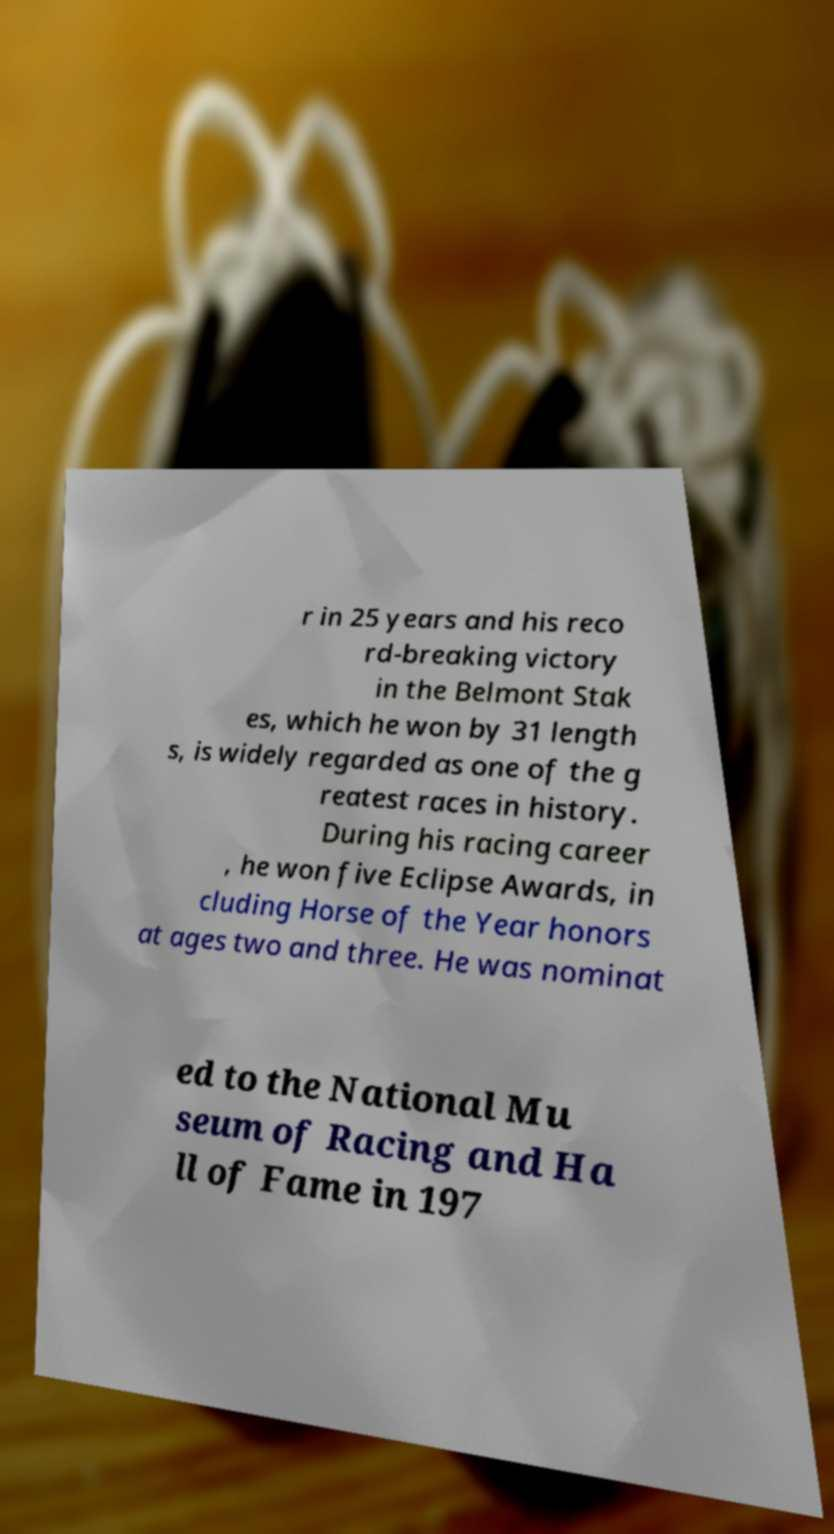Please read and relay the text visible in this image. What does it say? r in 25 years and his reco rd-breaking victory in the Belmont Stak es, which he won by 31 length s, is widely regarded as one of the g reatest races in history. During his racing career , he won five Eclipse Awards, in cluding Horse of the Year honors at ages two and three. He was nominat ed to the National Mu seum of Racing and Ha ll of Fame in 197 